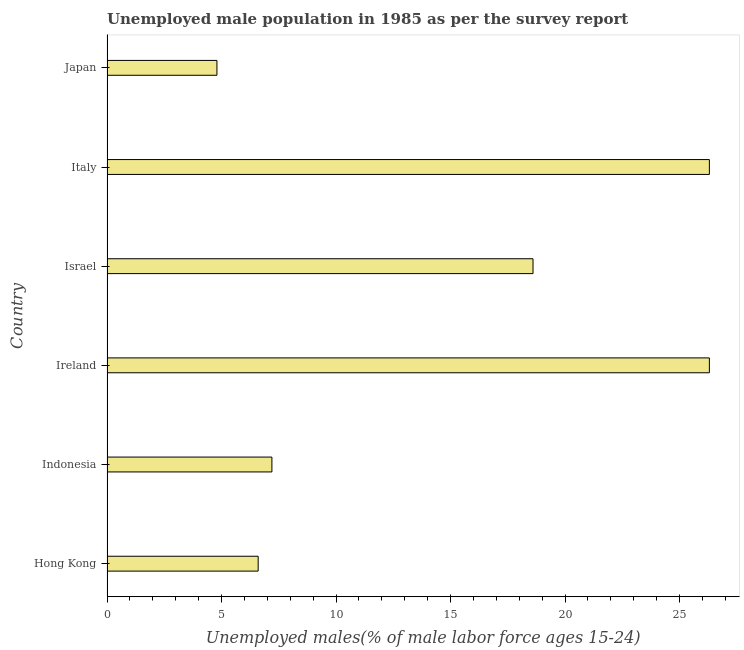What is the title of the graph?
Make the answer very short. Unemployed male population in 1985 as per the survey report. What is the label or title of the X-axis?
Your answer should be compact. Unemployed males(% of male labor force ages 15-24). What is the unemployed male youth in Indonesia?
Provide a short and direct response. 7.2. Across all countries, what is the maximum unemployed male youth?
Provide a short and direct response. 26.3. Across all countries, what is the minimum unemployed male youth?
Your answer should be very brief. 4.8. In which country was the unemployed male youth maximum?
Provide a succinct answer. Ireland. In which country was the unemployed male youth minimum?
Your response must be concise. Japan. What is the sum of the unemployed male youth?
Ensure brevity in your answer.  89.8. What is the difference between the unemployed male youth in Israel and Italy?
Your response must be concise. -7.7. What is the average unemployed male youth per country?
Keep it short and to the point. 14.97. What is the median unemployed male youth?
Your answer should be compact. 12.9. In how many countries, is the unemployed male youth greater than 5 %?
Provide a short and direct response. 5. What is the ratio of the unemployed male youth in Italy to that in Japan?
Your answer should be compact. 5.48. What is the difference between the highest and the lowest unemployed male youth?
Your answer should be very brief. 21.5. In how many countries, is the unemployed male youth greater than the average unemployed male youth taken over all countries?
Your response must be concise. 3. How many bars are there?
Offer a terse response. 6. Are all the bars in the graph horizontal?
Your answer should be compact. Yes. How many countries are there in the graph?
Provide a short and direct response. 6. Are the values on the major ticks of X-axis written in scientific E-notation?
Keep it short and to the point. No. What is the Unemployed males(% of male labor force ages 15-24) of Hong Kong?
Keep it short and to the point. 6.6. What is the Unemployed males(% of male labor force ages 15-24) of Indonesia?
Offer a very short reply. 7.2. What is the Unemployed males(% of male labor force ages 15-24) of Ireland?
Provide a succinct answer. 26.3. What is the Unemployed males(% of male labor force ages 15-24) in Israel?
Give a very brief answer. 18.6. What is the Unemployed males(% of male labor force ages 15-24) of Italy?
Your answer should be very brief. 26.3. What is the Unemployed males(% of male labor force ages 15-24) in Japan?
Make the answer very short. 4.8. What is the difference between the Unemployed males(% of male labor force ages 15-24) in Hong Kong and Indonesia?
Provide a succinct answer. -0.6. What is the difference between the Unemployed males(% of male labor force ages 15-24) in Hong Kong and Ireland?
Ensure brevity in your answer.  -19.7. What is the difference between the Unemployed males(% of male labor force ages 15-24) in Hong Kong and Israel?
Your answer should be compact. -12. What is the difference between the Unemployed males(% of male labor force ages 15-24) in Hong Kong and Italy?
Make the answer very short. -19.7. What is the difference between the Unemployed males(% of male labor force ages 15-24) in Hong Kong and Japan?
Offer a very short reply. 1.8. What is the difference between the Unemployed males(% of male labor force ages 15-24) in Indonesia and Ireland?
Provide a short and direct response. -19.1. What is the difference between the Unemployed males(% of male labor force ages 15-24) in Indonesia and Italy?
Keep it short and to the point. -19.1. What is the difference between the Unemployed males(% of male labor force ages 15-24) in Indonesia and Japan?
Your answer should be very brief. 2.4. What is the difference between the Unemployed males(% of male labor force ages 15-24) in Ireland and Japan?
Provide a short and direct response. 21.5. What is the difference between the Unemployed males(% of male labor force ages 15-24) in Israel and Italy?
Keep it short and to the point. -7.7. What is the difference between the Unemployed males(% of male labor force ages 15-24) in Israel and Japan?
Give a very brief answer. 13.8. What is the ratio of the Unemployed males(% of male labor force ages 15-24) in Hong Kong to that in Indonesia?
Provide a succinct answer. 0.92. What is the ratio of the Unemployed males(% of male labor force ages 15-24) in Hong Kong to that in Ireland?
Provide a short and direct response. 0.25. What is the ratio of the Unemployed males(% of male labor force ages 15-24) in Hong Kong to that in Israel?
Your response must be concise. 0.35. What is the ratio of the Unemployed males(% of male labor force ages 15-24) in Hong Kong to that in Italy?
Your answer should be compact. 0.25. What is the ratio of the Unemployed males(% of male labor force ages 15-24) in Hong Kong to that in Japan?
Make the answer very short. 1.38. What is the ratio of the Unemployed males(% of male labor force ages 15-24) in Indonesia to that in Ireland?
Give a very brief answer. 0.27. What is the ratio of the Unemployed males(% of male labor force ages 15-24) in Indonesia to that in Israel?
Offer a very short reply. 0.39. What is the ratio of the Unemployed males(% of male labor force ages 15-24) in Indonesia to that in Italy?
Provide a succinct answer. 0.27. What is the ratio of the Unemployed males(% of male labor force ages 15-24) in Indonesia to that in Japan?
Keep it short and to the point. 1.5. What is the ratio of the Unemployed males(% of male labor force ages 15-24) in Ireland to that in Israel?
Your response must be concise. 1.41. What is the ratio of the Unemployed males(% of male labor force ages 15-24) in Ireland to that in Japan?
Offer a very short reply. 5.48. What is the ratio of the Unemployed males(% of male labor force ages 15-24) in Israel to that in Italy?
Give a very brief answer. 0.71. What is the ratio of the Unemployed males(% of male labor force ages 15-24) in Israel to that in Japan?
Keep it short and to the point. 3.88. What is the ratio of the Unemployed males(% of male labor force ages 15-24) in Italy to that in Japan?
Make the answer very short. 5.48. 